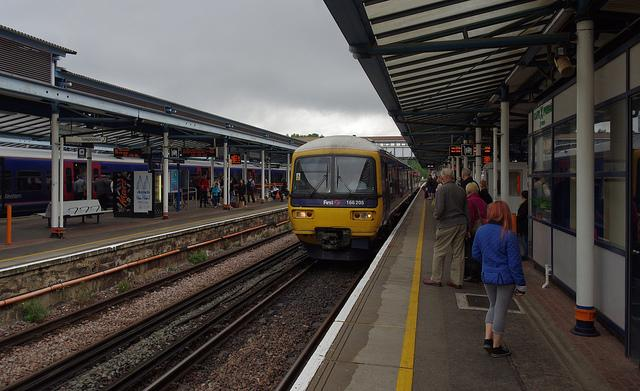At what locale do the people stand? Please explain your reasoning. train depot. The people are waiting to get on the yellow train. 